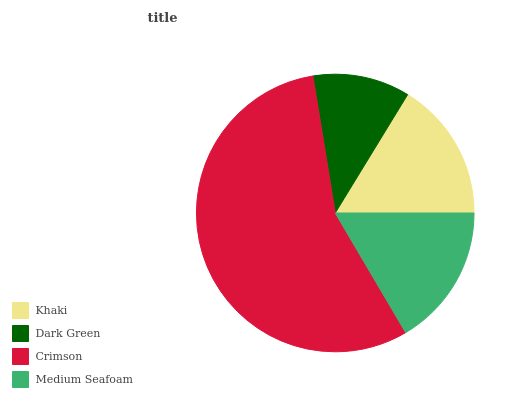Is Dark Green the minimum?
Answer yes or no. Yes. Is Crimson the maximum?
Answer yes or no. Yes. Is Crimson the minimum?
Answer yes or no. No. Is Dark Green the maximum?
Answer yes or no. No. Is Crimson greater than Dark Green?
Answer yes or no. Yes. Is Dark Green less than Crimson?
Answer yes or no. Yes. Is Dark Green greater than Crimson?
Answer yes or no. No. Is Crimson less than Dark Green?
Answer yes or no. No. Is Medium Seafoam the high median?
Answer yes or no. Yes. Is Khaki the low median?
Answer yes or no. Yes. Is Dark Green the high median?
Answer yes or no. No. Is Dark Green the low median?
Answer yes or no. No. 